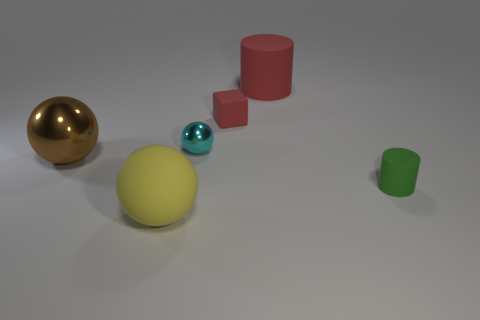Subtract all big balls. How many balls are left? 1 Add 1 tiny red things. How many objects exist? 7 Subtract all brown spheres. How many spheres are left? 2 Subtract all blocks. How many objects are left? 5 Add 3 brown things. How many brown things exist? 4 Subtract 0 cyan blocks. How many objects are left? 6 Subtract 1 spheres. How many spheres are left? 2 Subtract all brown cylinders. Subtract all green balls. How many cylinders are left? 2 Subtract all gray cylinders. How many green blocks are left? 0 Subtract all red cubes. Subtract all large yellow things. How many objects are left? 4 